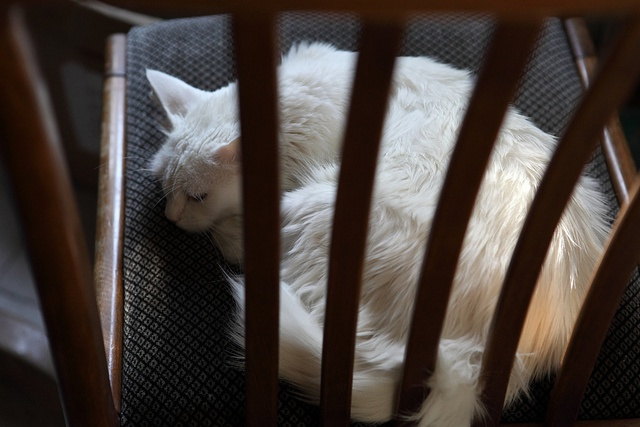Describe the objects in this image and their specific colors. I can see chair in black, gray, darkgray, and lightgray tones and cat in black, darkgray, lightgray, and gray tones in this image. 